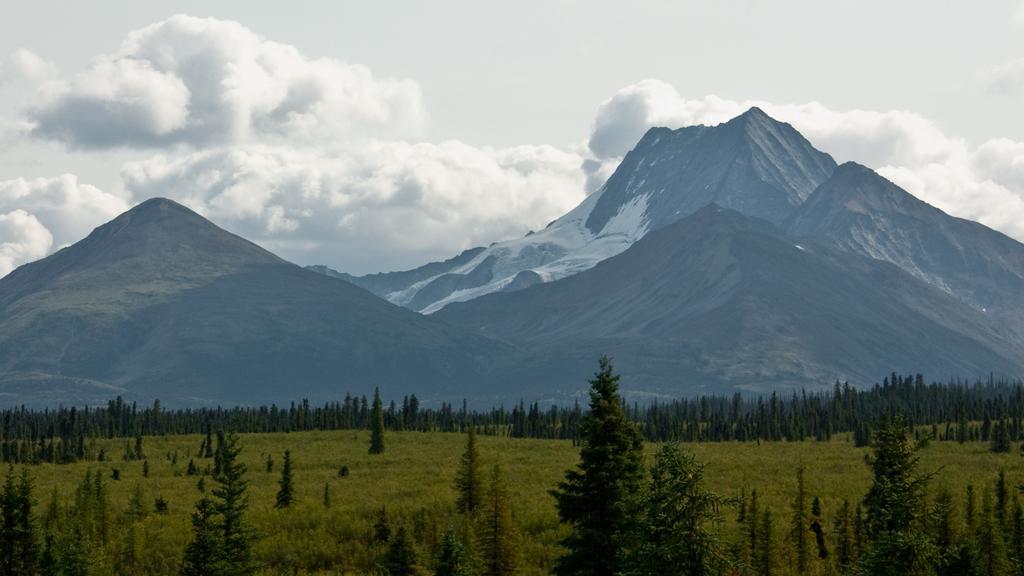In one or two sentences, can you explain what this image depicts? There are many trees and plants. In the background there are mountains and sky with clouds. 